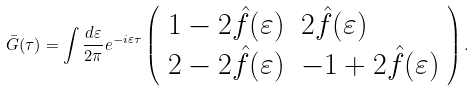Convert formula to latex. <formula><loc_0><loc_0><loc_500><loc_500>\bar { G } ( \tau ) = \int \frac { d \varepsilon } { 2 \pi } e ^ { - i \varepsilon \tau } \left ( \begin{array} { l l } 1 - 2 \hat { f } ( \varepsilon ) & 2 \hat { f } ( \varepsilon ) \\ 2 - 2 \hat { f } ( \varepsilon ) & - 1 + 2 \hat { f } ( \varepsilon ) \end{array} \right ) .</formula> 